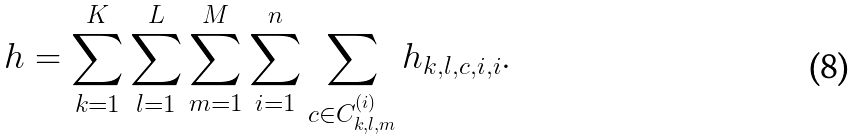Convert formula to latex. <formula><loc_0><loc_0><loc_500><loc_500>h = \sum _ { k = 1 } ^ { K } \sum _ { l = 1 } ^ { L } \sum _ { m = 1 } ^ { M } \sum _ { i = 1 } ^ { n } \sum _ { c \in C _ { k , l , m } ^ { ( i ) } } h _ { k , l , c , i , i } .</formula> 